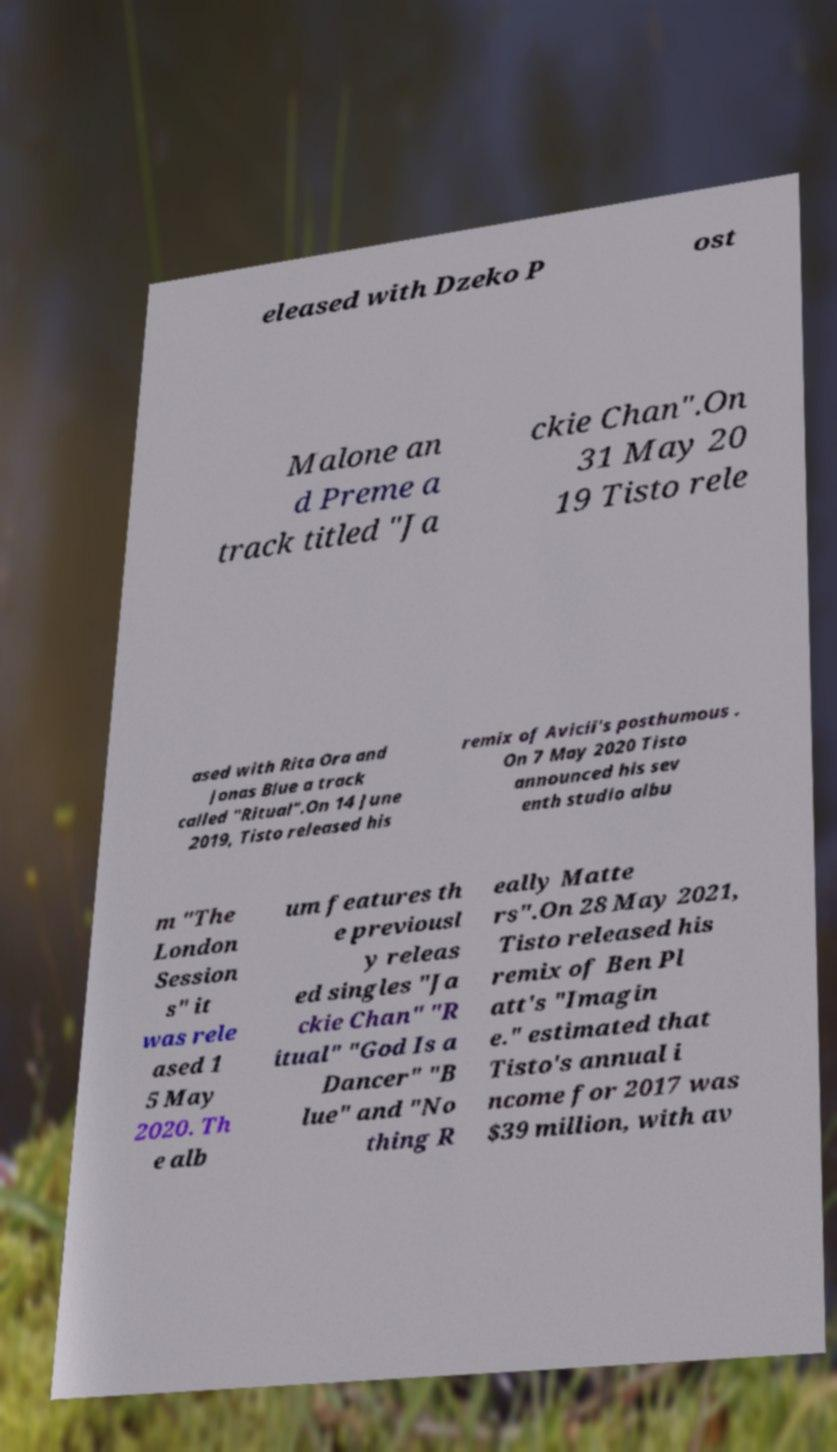Could you extract and type out the text from this image? eleased with Dzeko P ost Malone an d Preme a track titled "Ja ckie Chan".On 31 May 20 19 Tisto rele ased with Rita Ora and Jonas Blue a track called "Ritual".On 14 June 2019, Tisto released his remix of Avicii's posthumous . On 7 May 2020 Tisto announced his sev enth studio albu m "The London Session s" it was rele ased 1 5 May 2020. Th e alb um features th e previousl y releas ed singles "Ja ckie Chan" "R itual" "God Is a Dancer" "B lue" and "No thing R eally Matte rs".On 28 May 2021, Tisto released his remix of Ben Pl att's "Imagin e." estimated that Tisto's annual i ncome for 2017 was $39 million, with av 